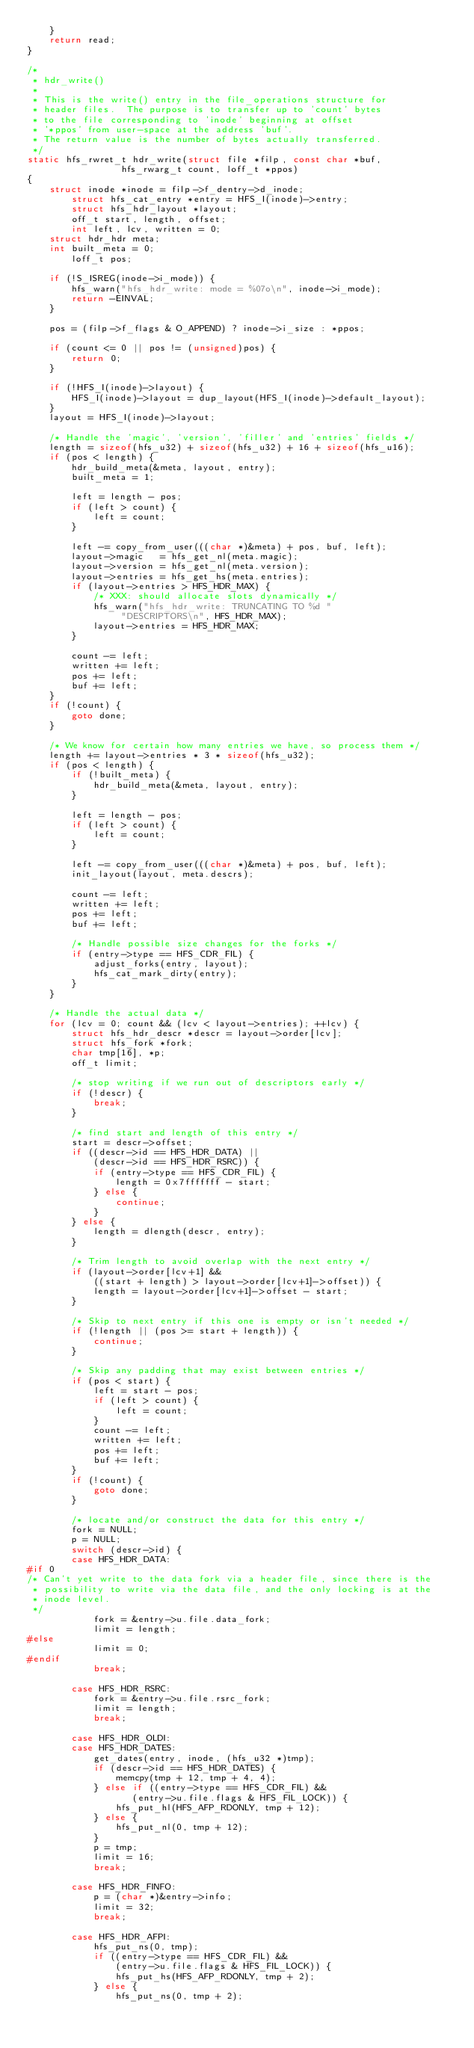Convert code to text. <code><loc_0><loc_0><loc_500><loc_500><_C_>	}
	return read;
}

/*
 * hdr_write()
 *
 * This is the write() entry in the file_operations structure for
 * header files.  The purpose is to transfer up to 'count' bytes
 * to the file corresponding to 'inode' beginning at offset
 * '*ppos' from user-space at the address 'buf'.
 * The return value is the number of bytes actually transferred.
 */
static hfs_rwret_t hdr_write(struct file *filp, const char *buf,
			     hfs_rwarg_t count, loff_t *ppos)
{
	struct inode *inode = filp->f_dentry->d_inode;
        struct hfs_cat_entry *entry = HFS_I(inode)->entry;
        struct hfs_hdr_layout *layout;
        off_t start, length, offset;
        int left, lcv, written = 0;
	struct hdr_hdr meta;
	int built_meta = 0;
        loff_t pos;

	if (!S_ISREG(inode->i_mode)) {
		hfs_warn("hfs_hdr_write: mode = %07o\n", inode->i_mode);
		return -EINVAL;
	}

	pos = (filp->f_flags & O_APPEND) ? inode->i_size : *ppos;

	if (count <= 0 || pos != (unsigned)pos) {
		return 0;
	}

	if (!HFS_I(inode)->layout) {
		HFS_I(inode)->layout = dup_layout(HFS_I(inode)->default_layout);
	}
	layout = HFS_I(inode)->layout;

	/* Handle the 'magic', 'version', 'filler' and 'entries' fields */
	length = sizeof(hfs_u32) + sizeof(hfs_u32) + 16 + sizeof(hfs_u16);
	if (pos < length) {
		hdr_build_meta(&meta, layout, entry);
		built_meta = 1;

		left = length - pos;
		if (left > count) {
			left = count;
		}

		left -= copy_from_user(((char *)&meta) + pos, buf, left);
		layout->magic   = hfs_get_nl(meta.magic);
		layout->version = hfs_get_nl(meta.version);
		layout->entries = hfs_get_hs(meta.entries);
		if (layout->entries > HFS_HDR_MAX) {
			/* XXX: should allocate slots dynamically */
			hfs_warn("hfs_hdr_write: TRUNCATING TO %d "
				 "DESCRIPTORS\n", HFS_HDR_MAX);
			layout->entries = HFS_HDR_MAX;
		}

		count -= left;
		written += left;
		pos += left;
		buf += left;
	}
	if (!count) {
		goto done;
	}

	/* We know for certain how many entries we have, so process them */
	length += layout->entries * 3 * sizeof(hfs_u32);
	if (pos < length) {
		if (!built_meta) {
			hdr_build_meta(&meta, layout, entry);
		}

		left = length - pos;
		if (left > count) {
			left = count;
		}

		left -= copy_from_user(((char *)&meta) + pos, buf, left);
		init_layout(layout, meta.descrs);

		count -= left;
		written += left;
		pos += left;
		buf += left;

		/* Handle possible size changes for the forks */
		if (entry->type == HFS_CDR_FIL) {
			adjust_forks(entry, layout);
			hfs_cat_mark_dirty(entry);
		}
	}

	/* Handle the actual data */
	for (lcv = 0; count && (lcv < layout->entries); ++lcv) {
		struct hfs_hdr_descr *descr = layout->order[lcv];
		struct hfs_fork *fork;
		char tmp[16], *p;
		off_t limit;

		/* stop writing if we run out of descriptors early */
		if (!descr) {
			break;
		}

		/* find start and length of this entry */
		start = descr->offset;
		if ((descr->id == HFS_HDR_DATA) ||
		    (descr->id == HFS_HDR_RSRC)) {
			if (entry->type == HFS_CDR_FIL) {
				length = 0x7fffffff - start;
			} else {
				continue;
			}
		} else {
			length = dlength(descr, entry);
		}

		/* Trim length to avoid overlap with the next entry */
		if (layout->order[lcv+1] &&
		    ((start + length) > layout->order[lcv+1]->offset)) {
			length = layout->order[lcv+1]->offset - start;
		}

		/* Skip to next entry if this one is empty or isn't needed */
		if (!length || (pos >= start + length)) {
			continue;
		}

		/* Skip any padding that may exist between entries */
		if (pos < start) {
			left = start - pos;
			if (left > count) {
				left = count;
			}
			count -= left;
			written += left;
			pos += left;
			buf += left;
		}
		if (!count) {
			goto done;
		}

		/* locate and/or construct the data for this entry */
		fork = NULL;
		p = NULL;
		switch (descr->id) {
		case HFS_HDR_DATA:
#if 0
/* Can't yet write to the data fork via a header file, since there is the
 * possibility to write via the data file, and the only locking is at the
 * inode level.
 */
			fork = &entry->u.file.data_fork;
			limit = length;
#else
			limit = 0;
#endif
			break;

		case HFS_HDR_RSRC:
			fork = &entry->u.file.rsrc_fork;
			limit = length;
			break;

		case HFS_HDR_OLDI:
		case HFS_HDR_DATES:
			get_dates(entry, inode, (hfs_u32 *)tmp);
			if (descr->id == HFS_HDR_DATES) {
				memcpy(tmp + 12, tmp + 4, 4);
			} else if ((entry->type == HFS_CDR_FIL) &&
				   (entry->u.file.flags & HFS_FIL_LOCK)) {
				hfs_put_hl(HFS_AFP_RDONLY, tmp + 12);
			} else {
				hfs_put_nl(0, tmp + 12);
			}
			p = tmp;
			limit = 16;
			break;

		case HFS_HDR_FINFO:
			p = (char *)&entry->info;
			limit = 32;
			break;

		case HFS_HDR_AFPI:
			hfs_put_ns(0, tmp);
			if ((entry->type == HFS_CDR_FIL) &&
			    (entry->u.file.flags & HFS_FIL_LOCK)) {
				hfs_put_hs(HFS_AFP_RDONLY, tmp + 2);
			} else {
				hfs_put_ns(0, tmp + 2);</code> 